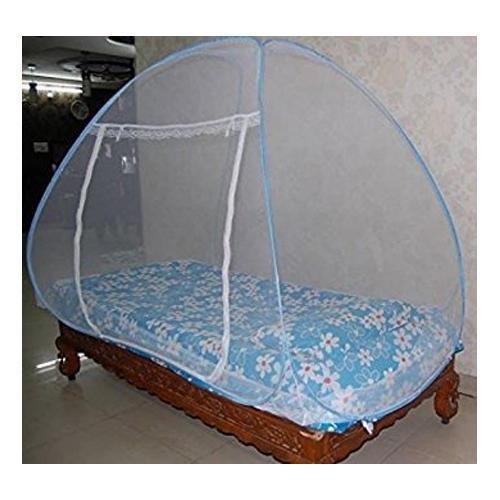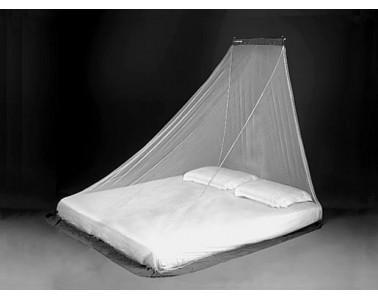The first image is the image on the left, the second image is the image on the right. For the images displayed, is the sentence "Two or more pillows are visible." factually correct? Answer yes or no. Yes. The first image is the image on the left, the second image is the image on the right. Assess this claim about the two images: "There are two pillows in the right image.". Correct or not? Answer yes or no. Yes. 